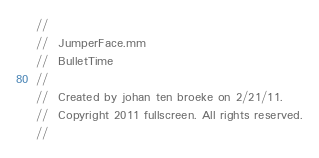<code> <loc_0><loc_0><loc_500><loc_500><_ObjectiveC_>//
//  JumperFace.mm
//  BulletTime
//
//  Created by johan ten broeke on 2/21/11.
//  Copyright 2011 fullscreen. All rights reserved.
//
</code> 